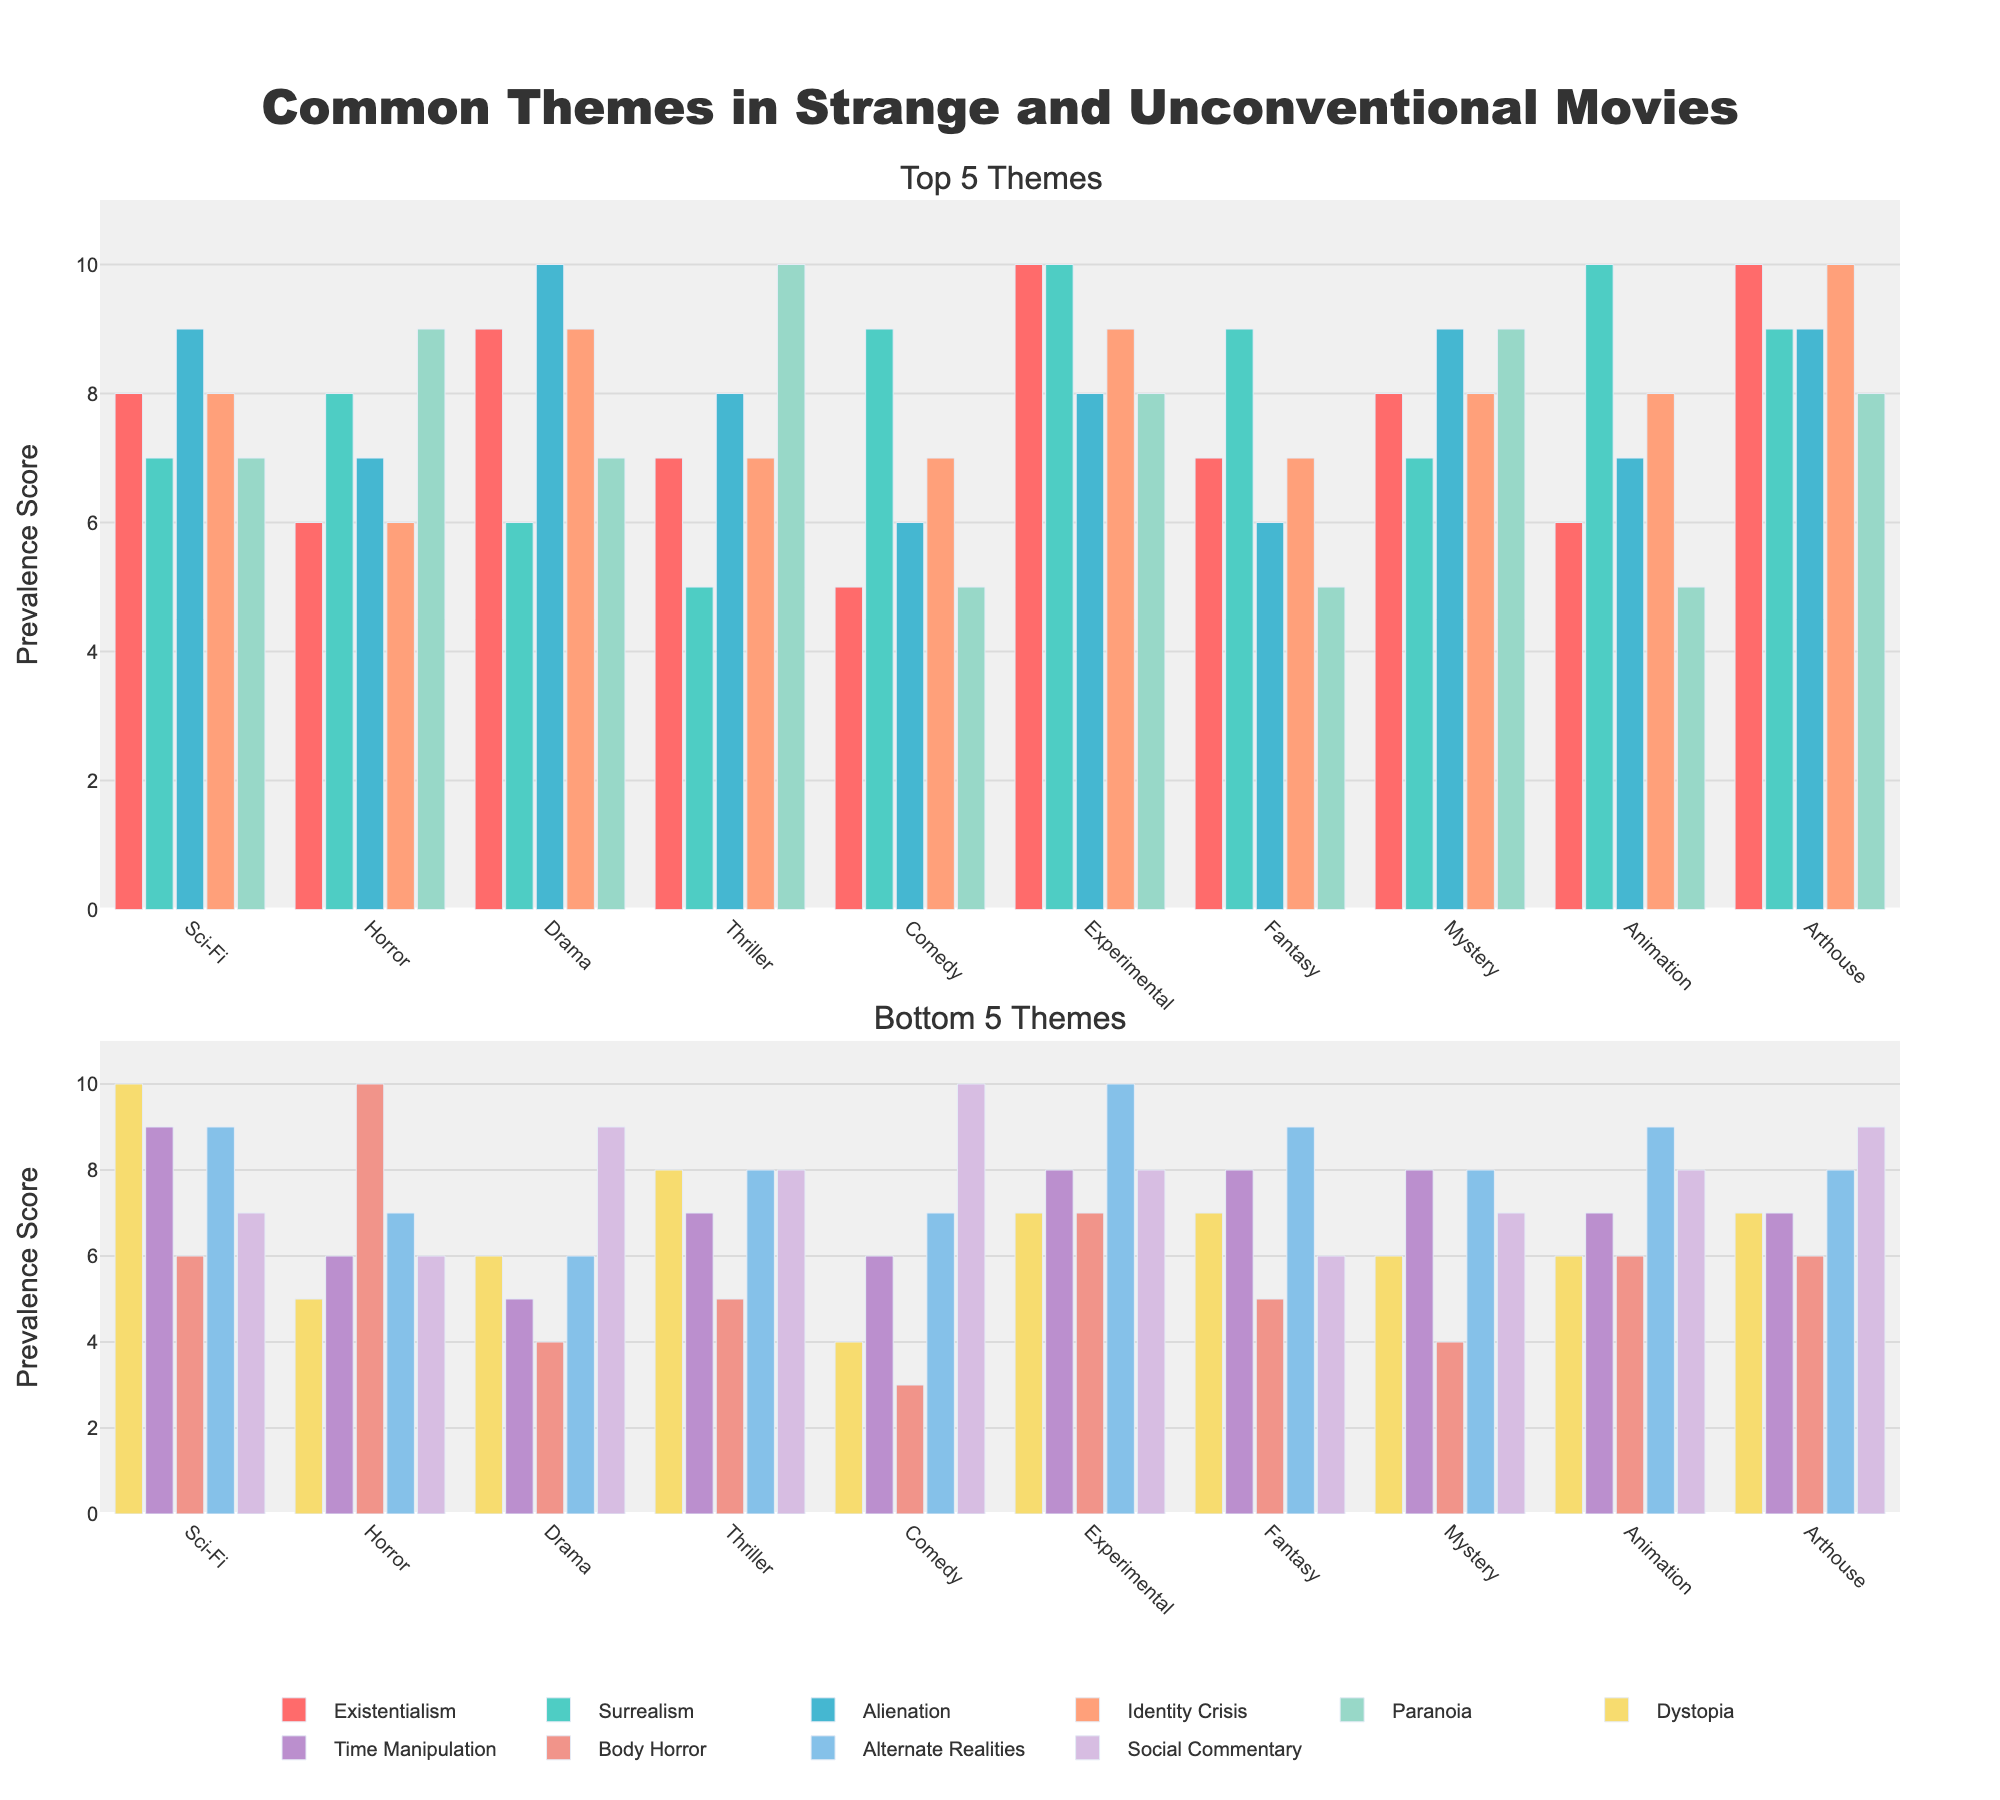What's the genre with the highest score for the theme of Body Horror? Look at the bar heights or scores for the theme "Body Horror". The highest score is in Horror with a score of 10.
Answer: Horror Which theme has the lowest average score across all genres in the entire figure? Calculate the average scores for each theme across all genres: Time Manipulation (7.3), Body Horror (6.2), Alternate Realities (8.1), Social Commentary (7.8), etc. The theme with the lowest average needs to be identified visually or through calculations.
Answer: Body Horror Which genre displays the most balance, with similar scores across all themes? Observe the variance in bar heights for each genre. Experimental has more even scores across themes compared to other genres.
Answer: Experimental How many more points does Sci-Fi receive for Dystopia compared to Comedy for the same theme? Subtract the score of Comedy (4) from Sci-Fi (10) for the theme "Dystopia". 10 - 4 = 6.
Answer: 6 Are there any themes where both Arthouse and Experimental genres score exactly the same? Compare scores for each theme for both Arthouse and Experimental. They both have the same score in the Body Horror (7) and Alternate Realities (8) themes.
Answer: Body Horror, Alternate Realities Which theme appears most frequently as the highest score within any single genre? Scan each genre’s highest scores and tally the occurrences for each theme to identify the most common one. Identity Crisis appears frequently as the top score.
Answer: Identity Crisis In the Drama genre, what is the difference between the highest and lowest theme scores? The highest theme score in Drama is Identity Crisis (10) and the lowest is Body Horror (4), so the difference is 10 - 4 = 6.
Answer: 6 What is the average score of Surrealism across Sci-Fi, Horror, and Drama genres? Add scores of Surrealism for Sci-Fi (7), Horror (8), and Drama (6), then divide by 3. (7 + 8 + 6)/3 = 7.
Answer: 7 Which genre has the lowest total score for the top 5 themes? Sum the scores for the top 5 themes for each genre and identify the genre with the smallest total. Comedy (5+9+6+7+5=32) has the lowest total for the top 5 themes.
Answer: Comedy 